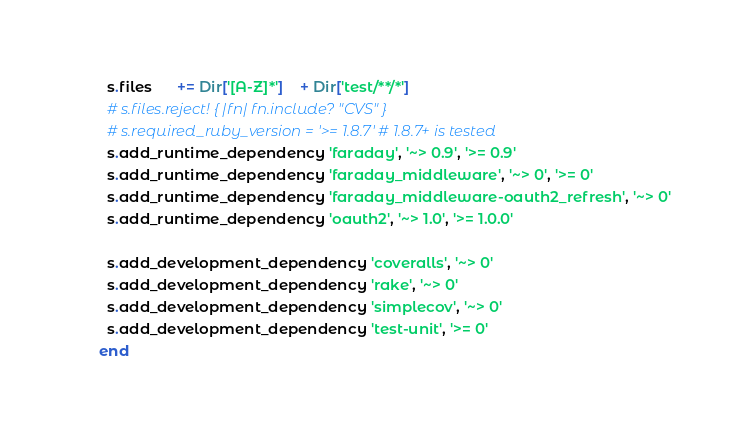<code> <loc_0><loc_0><loc_500><loc_500><_Ruby_>  s.files      += Dir['[A-Z]*']    + Dir['test/**/*']
  # s.files.reject! { |fn| fn.include? "CVS" }
  # s.required_ruby_version = '>= 1.8.7' # 1.8.7+ is tested
  s.add_runtime_dependency 'faraday', '~> 0.9', '>= 0.9'
  s.add_runtime_dependency 'faraday_middleware', '~> 0', '>= 0'
  s.add_runtime_dependency 'faraday_middleware-oauth2_refresh', '~> 0'
  s.add_runtime_dependency 'oauth2', '~> 1.0', '>= 1.0.0'

  s.add_development_dependency 'coveralls', '~> 0'
  s.add_development_dependency 'rake', '~> 0'
  s.add_development_dependency 'simplecov', '~> 0'
  s.add_development_dependency 'test-unit', '>= 0'
end
</code> 